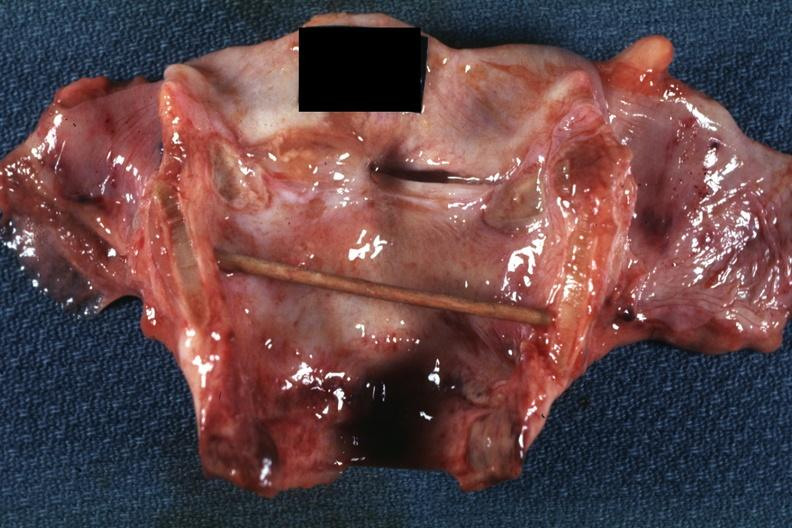does angiogram show excellent example intubation lesion with tracheitis?
Answer the question using a single word or phrase. No 